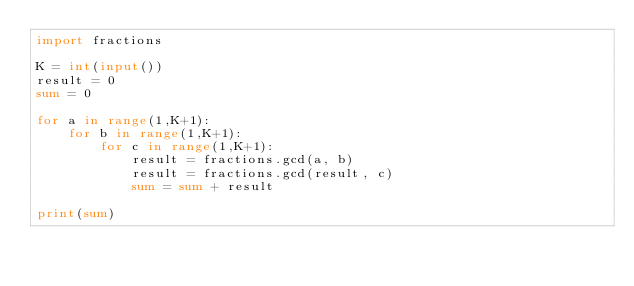<code> <loc_0><loc_0><loc_500><loc_500><_Python_>import fractions

K = int(input())
result = 0
sum = 0

for a in range(1,K+1):
    for b in range(1,K+1):
        for c in range(1,K+1):
            result = fractions.gcd(a, b)
            result = fractions.gcd(result, c)
            sum = sum + result

print(sum)  </code> 